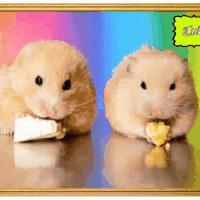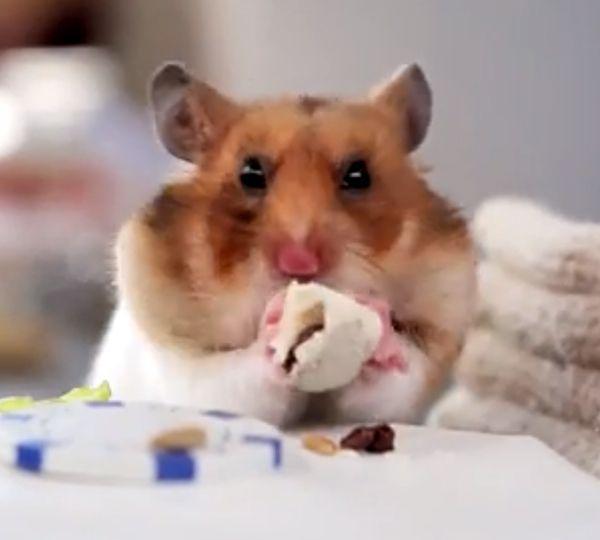The first image is the image on the left, the second image is the image on the right. For the images displayed, is the sentence "Two hamsters have something green in their mouths." factually correct? Answer yes or no. No. 